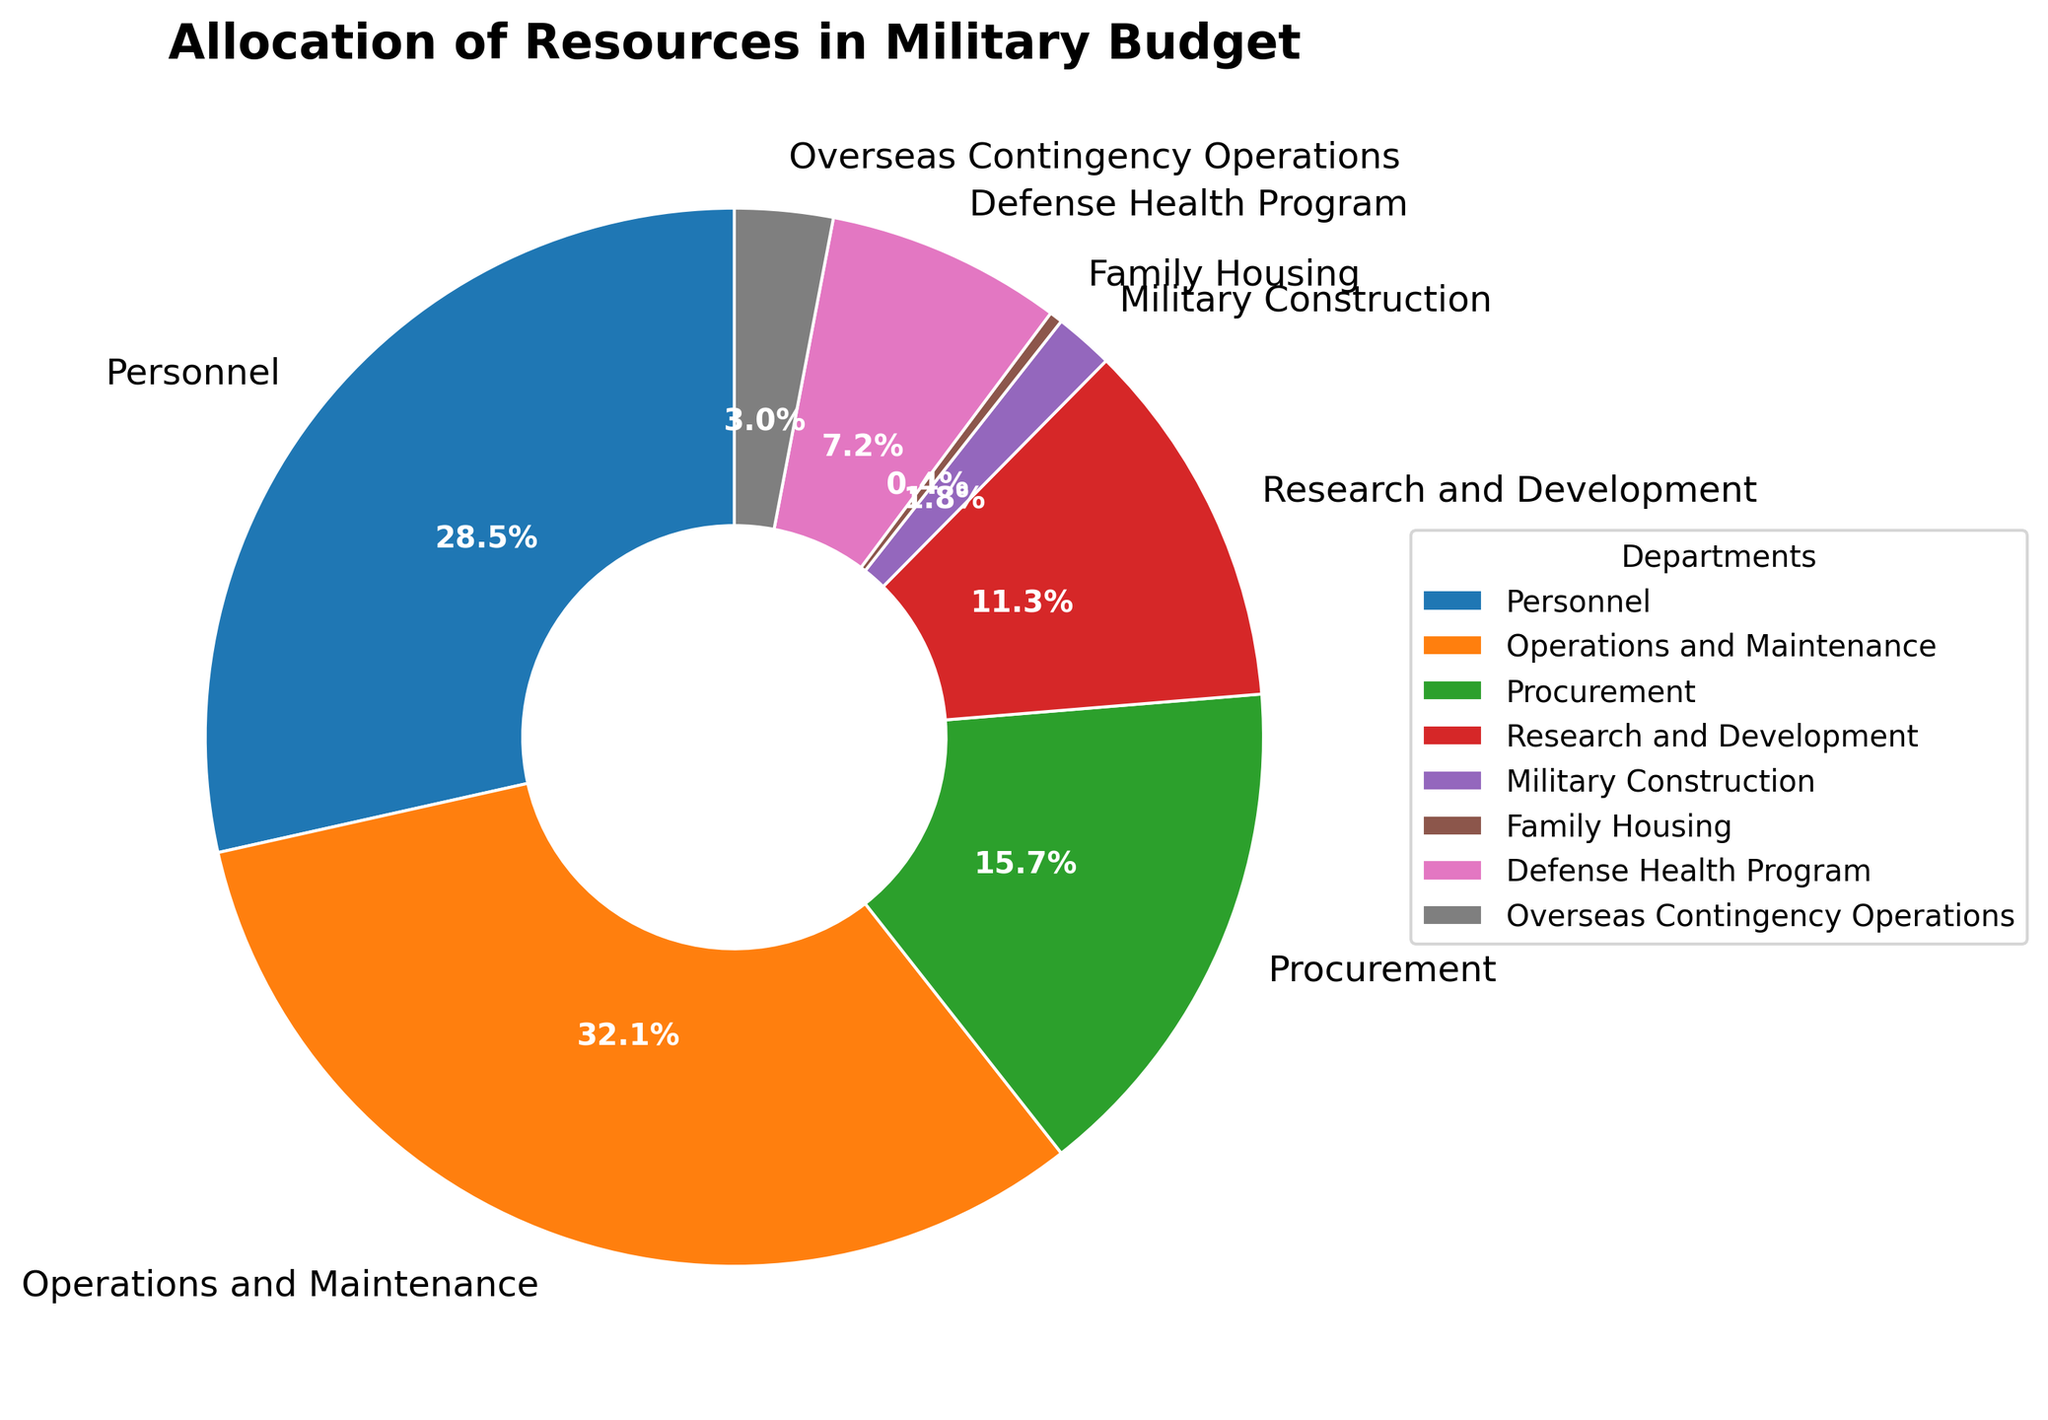What is the largest percentage allocation in the military budget? To find the largest percentage allocation, scan through the chart to find the segment with the highest percentage. The "Operations and Maintenance" segment has the largest slice, labeled as 32.1%.
Answer: 32.1% Which department has the smallest allocation in the military budget? To determine the department with the smallest allocation, look for the smallest slice. The "Family Housing" segment, labeled 0.4%, represents the smallest allocation.
Answer: Family Housing What is the combined percentage of Personnel and Research and Development? Identify the two relevant slices: "Personnel" at 28.5% and "Research and Development" at 11.3%. Add these two percentages together to find the total: 28.5% + 11.3% = 39.8%.
Answer: 39.8% How does the allocation for Overseas Contingency Operations compare to Military Construction? To compare the two, first identify their percentages: "Overseas Contingency Operations" at 3.0% and "Military Construction" at 1.8%. Overseas Contingency Operations has a larger allocation.
Answer: Overseas Contingency Operations Which department is represented by the green slice in the chart? Identify the green slice and match it to the department label. The green slice corresponds to the "Procurement" department.
Answer: Procurement What is the difference in percentage between Operations and Maintenance and Defense Health Program? Calculate the difference by subtracting the smaller percentage from the larger one: 32.1% (Operations and Maintenance) - 7.2% (Defense Health Program) = 24.9%.
Answer: 24.9% What is the total percentage of all departments except Operations and Maintenance? Sum the percentages of all other departments: 28.5% (Personnel) + 15.7% (Procurement) + 11.3% (Research and Development) + 1.8% (Military Construction) + 0.4% (Family Housing) + 7.2% (Defense Health Program) + 3.0% (Overseas Contingency Operations) = 67.9%.
Answer: 67.9% Which two departments combined form a percentage closest to 50%? Calculate the sums of different department pairs to find the closest to 50%. Personnel (28.5%) + Research and Development (11.3%) = 39.8%, Operations and Maintenance (32.1%) + Procurement (15.7%) = 47.8%. The closest combination is Operations and Maintenance and Procurement, which total 47.8%.
Answer: Operations and Maintenance and Procurement What percentage is allocated to departments other than the top three? First, identify the top three departments by percentage: Operations and Maintenance (32.1%), Personnel (28.5%), Procurement (15.7%). Add their percentages: 32.1% + 28.5% + 15.7% = 76.3%. Now, subtract from 100%: 100% - 76.3% = 23.7%.
Answer: 23.7% What is the average percentage allocation per department? To find the average, sum all the percentages and divide by the number of departments: (28.5% + 32.1% + 15.7% + 11.3% + 1.8% + 0.4% + 7.2% + 3.0%) / 8 = 12.5%.
Answer: 12.5% 